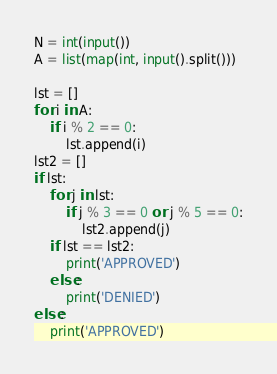Convert code to text. <code><loc_0><loc_0><loc_500><loc_500><_Python_>N = int(input())
A = list(map(int, input().split()))

lst = []
for i in A:
    if i % 2 == 0:
        lst.append(i)
lst2 = []
if lst:
    for j in lst:
        if j % 3 == 0 or j % 5 == 0:
            lst2.append(j)
    if lst == lst2:
        print('APPROVED')
    else:
        print('DENIED')
else:
    print('APPROVED')</code> 